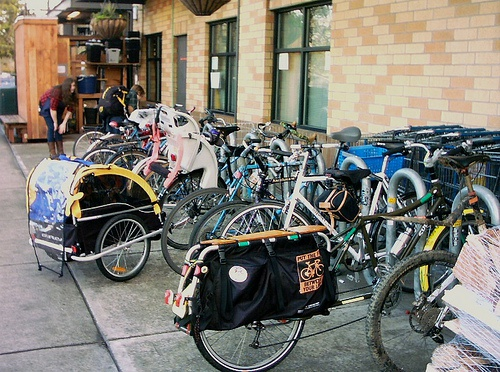Describe the objects in this image and their specific colors. I can see bicycle in gray, black, darkgray, and lightgray tones, bicycle in gray, black, lightgray, and darkgray tones, bicycle in gray, black, darkgray, and lightgray tones, bicycle in gray, black, purple, and darkgray tones, and bicycle in gray, lightgray, black, and darkgray tones in this image. 